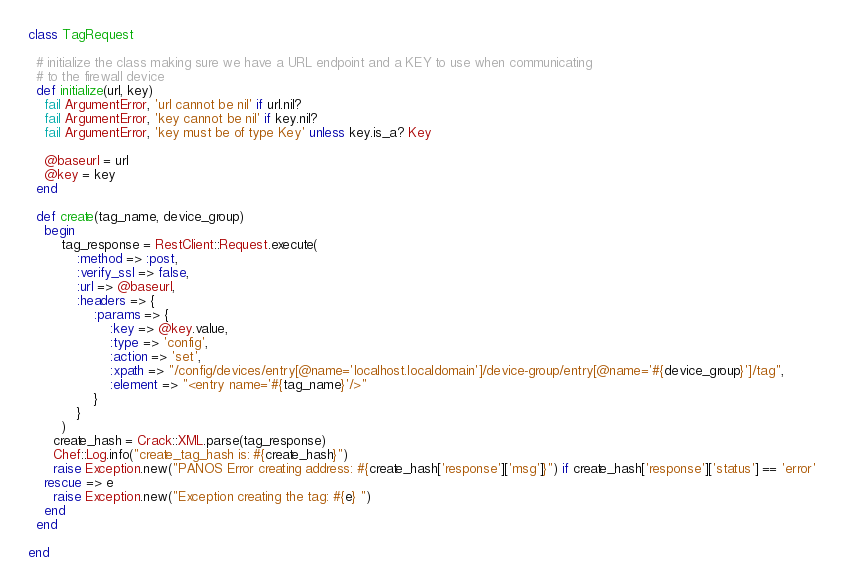Convert code to text. <code><loc_0><loc_0><loc_500><loc_500><_Ruby_>class TagRequest

  # initialize the class making sure we have a URL endpoint and a KEY to use when communicating
  # to the firewall device
  def initialize(url, key)
    fail ArgumentError, 'url cannot be nil' if url.nil?
    fail ArgumentError, 'key cannot be nil' if key.nil?
    fail ArgumentError, 'key must be of type Key' unless key.is_a? Key

    @baseurl = url
    @key = key
  end

  def create(tag_name, device_group)
    begin
    	tag_response = RestClient::Request.execute(
    		:method => :post,
    		:verify_ssl => false,
    		:url => @baseurl,
    		:headers => {
    			:params => {
    				:key => @key.value,
    				:type => 'config',
    				:action => 'set',
    				:xpath => "/config/devices/entry[@name='localhost.localdomain']/device-group/entry[@name='#{device_group}']/tag",
    				:element => "<entry name='#{tag_name}'/>"
    			}
    		}
    	)
      create_hash = Crack::XML.parse(tag_response)
      Chef::Log.info("create_tag_hash is: #{create_hash}")
      raise Exception.new("PANOS Error creating address: #{create_hash['response']['msg']}") if create_hash['response']['status'] == 'error'
    rescue => e
      raise Exception.new("Exception creating the tag: #{e} ")
    end
  end

end
</code> 